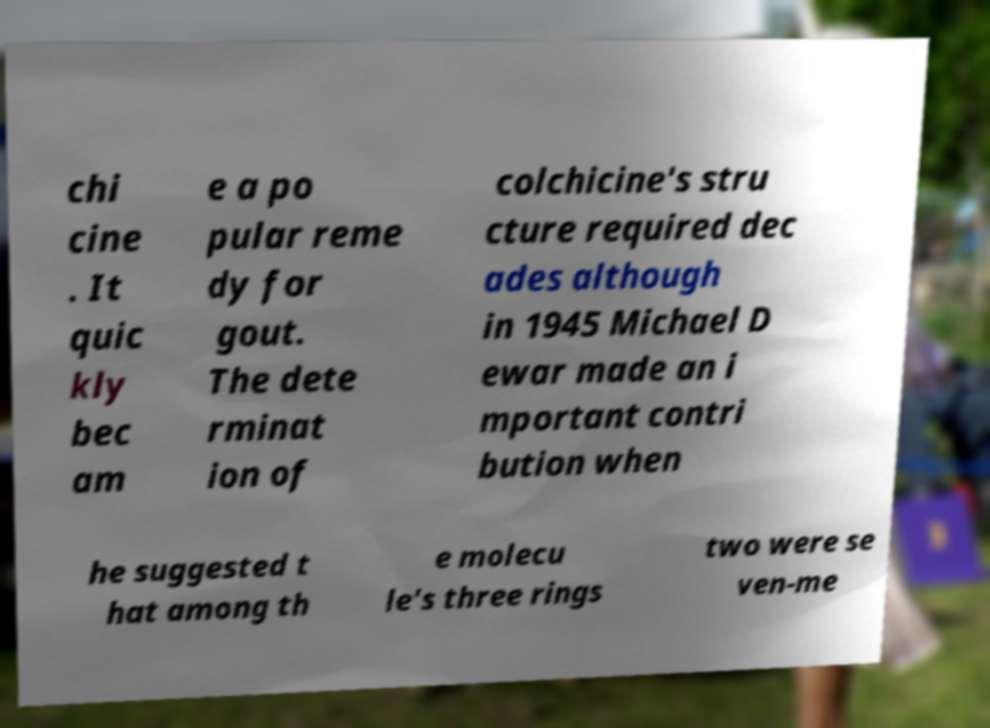There's text embedded in this image that I need extracted. Can you transcribe it verbatim? chi cine . It quic kly bec am e a po pular reme dy for gout. The dete rminat ion of colchicine's stru cture required dec ades although in 1945 Michael D ewar made an i mportant contri bution when he suggested t hat among th e molecu le's three rings two were se ven-me 